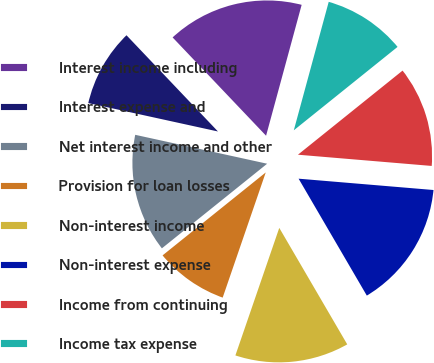Convert chart to OTSL. <chart><loc_0><loc_0><loc_500><loc_500><pie_chart><fcel>Interest income including<fcel>Interest expense and<fcel>Net interest income and other<fcel>Provision for loan losses<fcel>Non-interest income<fcel>Non-interest expense<fcel>Income from continuing<fcel>Income tax expense<nl><fcel>16.32%<fcel>9.47%<fcel>14.21%<fcel>8.95%<fcel>13.68%<fcel>15.26%<fcel>12.11%<fcel>10.0%<nl></chart> 